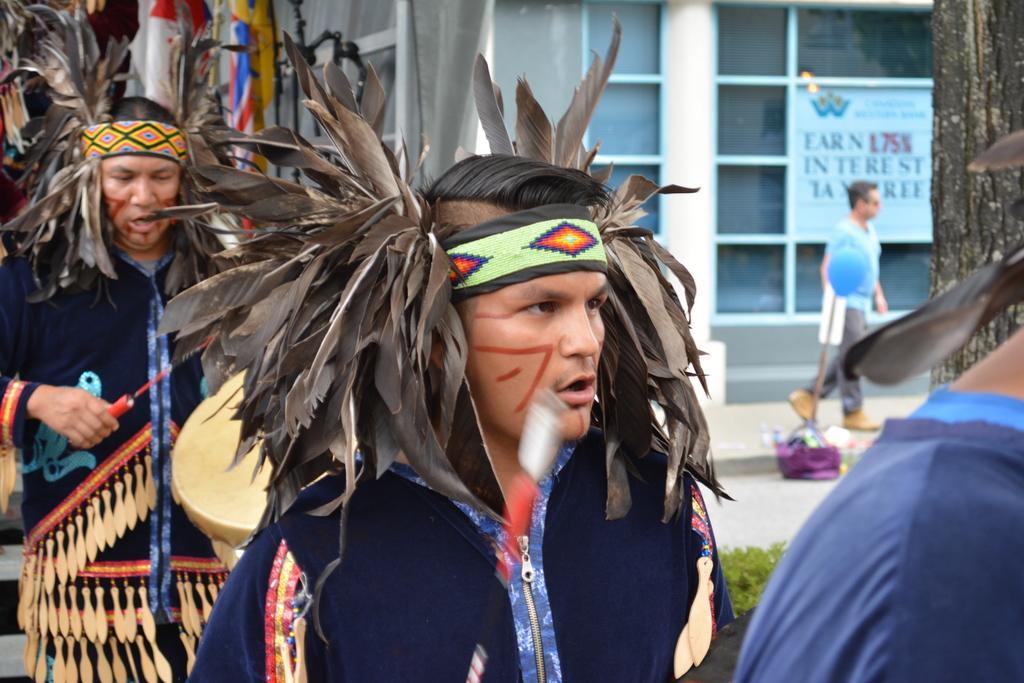Can you describe this image briefly? In the background we can see a building. This is a board. At the right side of the picture we can see a branch, a person walking, and a bag. Here we can see three men and these are quills. 